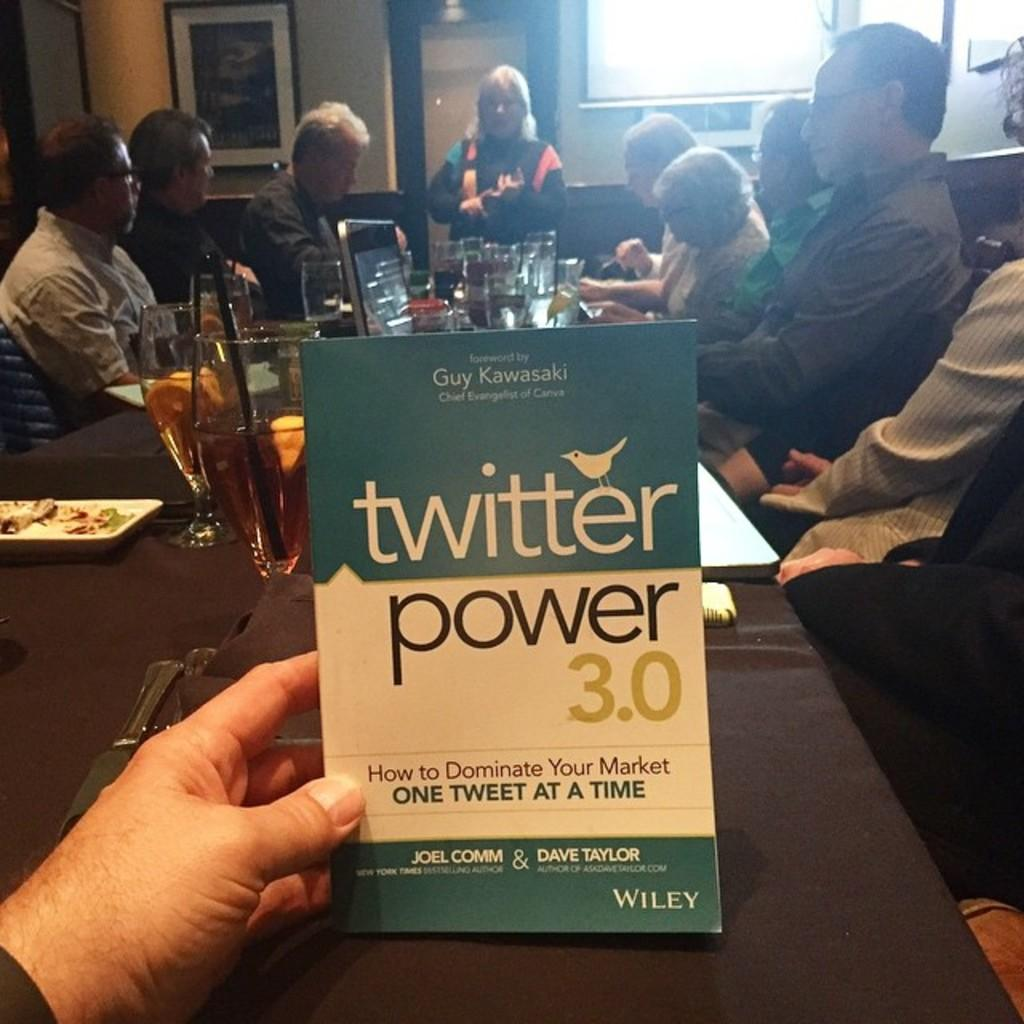Provide a one-sentence caption for the provided image. An ad has the twitter logo on it and is being held in someone's hand. 